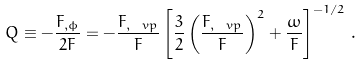Convert formula to latex. <formula><loc_0><loc_0><loc_500><loc_500>Q \equiv - \frac { F _ { , \phi } } { 2 F } = - \frac { F _ { , \ v p } } { F } \left [ \frac { 3 } { 2 } \left ( \frac { F _ { , \ v p } } { F } \right ) ^ { 2 } + \frac { \omega } { F } \right ] ^ { - 1 / 2 } \, .</formula> 